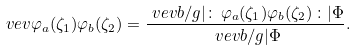Convert formula to latex. <formula><loc_0><loc_0><loc_500><loc_500>\ v e v { \varphi _ { a } ( \zeta _ { 1 } ) \varphi _ { b } ( \zeta _ { 2 } ) } & = \frac { \ v e v { b / g | \colon \, \varphi _ { a } ( \zeta _ { 1 } ) \varphi _ { b } ( \zeta _ { 2 } ) \, \colon | \Phi } } { \ v e v { b / g | \Phi } } .</formula> 